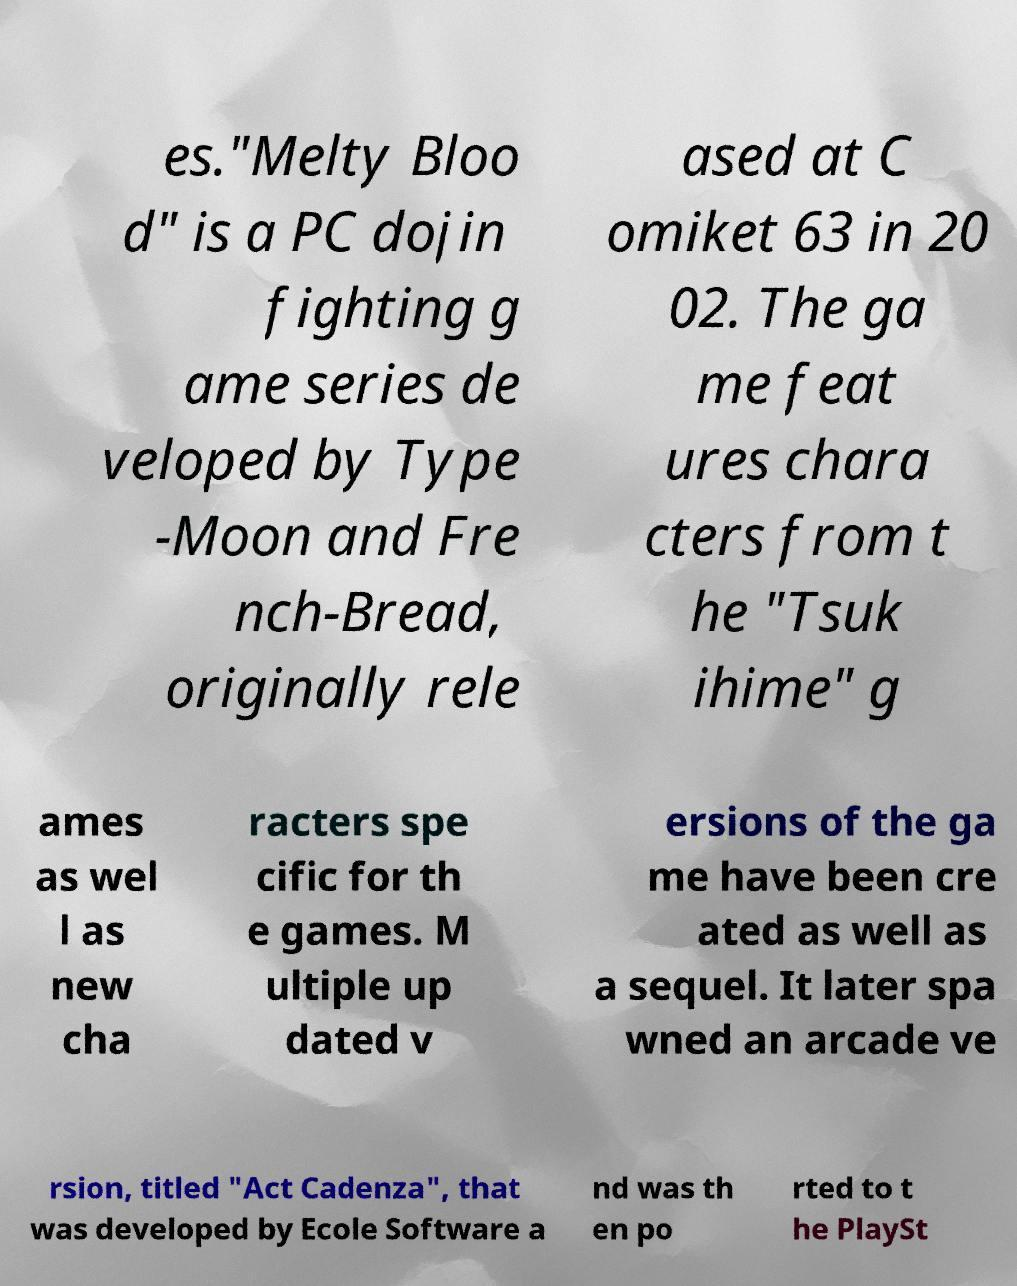What messages or text are displayed in this image? I need them in a readable, typed format. es."Melty Bloo d" is a PC dojin fighting g ame series de veloped by Type -Moon and Fre nch-Bread, originally rele ased at C omiket 63 in 20 02. The ga me feat ures chara cters from t he "Tsuk ihime" g ames as wel l as new cha racters spe cific for th e games. M ultiple up dated v ersions of the ga me have been cre ated as well as a sequel. It later spa wned an arcade ve rsion, titled "Act Cadenza", that was developed by Ecole Software a nd was th en po rted to t he PlaySt 